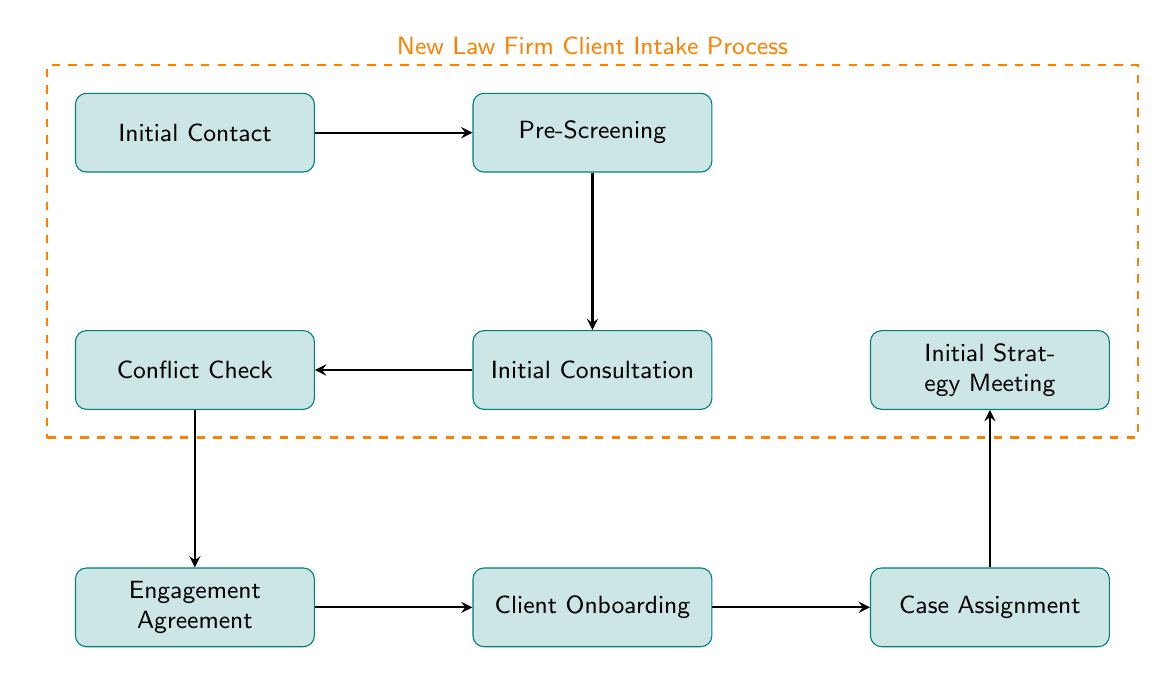What is the first step in the client intake process? The diagram indicates that the first step is "Initial Contact," where the potential client reaches out to the firm.
Answer: Initial Contact How many nodes are present in the diagram? By counting the different process nodes listed in the diagram, we find there are a total of eight nodes.
Answer: Eight What does the arrow from "Engagement Agreement" indicate? The arrow from "Engagement Agreement" points to "Client Onboarding," indicating that once the engagement agreement is provided, the next step is onboarding the client.
Answer: Client Onboarding What is the last step in the client intake process? Following the flow of the diagram, the last step is "Initial Strategy Meeting."
Answer: Initial Strategy Meeting Which node follows "Initial Consultation"? The node that follows "Initial Consultation" is "Conflict Check," which occurs after discussing case details with the client.
Answer: Conflict Check What is required before the "Engagement Agreement" is provided? The diagram shows that the "Conflict Check" must be conducted before providing the "Engagement Agreement" to ensure no conflicts of interest exist.
Answer: Conflict Check Which step comes after the "Client Onboarding"? According to the diagram, the step that follows "Client Onboarding" is "Case Assignment," where a dedicated legal team is assigned to manage the client's case.
Answer: Case Assignment What are the two processes that occur before the "Initial Consultation"? The two processes before "Initial Consultation" are "Pre-Screening," which gathers basic information, and "Initial Contact," where the potential client first reaches out.
Answer: Initial Contact, Pre-Screening 